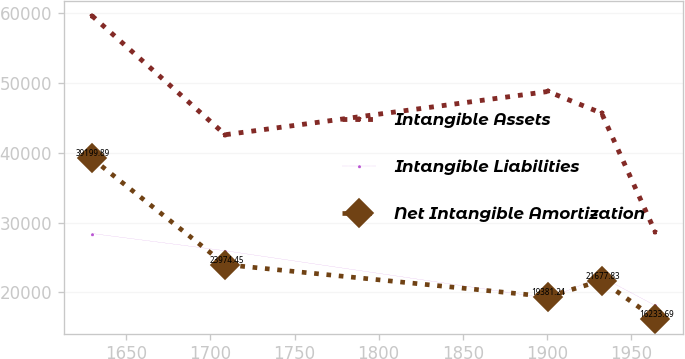<chart> <loc_0><loc_0><loc_500><loc_500><line_chart><ecel><fcel>Intangible Assets<fcel>Intangible Liabilities<fcel>Net Intangible Amortization<nl><fcel>1629.55<fcel>59668.5<fcel>28432.5<fcel>39199.9<nl><fcel>1708.8<fcel>42605.4<fcel>25958.4<fcel>23974.5<nl><fcel>1900.66<fcel>48806.3<fcel>19139.9<fcel>19381.2<nl><fcel>1932.54<fcel>45705.9<fcel>22190.5<fcel>21677.8<nl><fcel>1964.42<fcel>28663.9<fcel>18107.4<fcel>16233.7<nl></chart> 